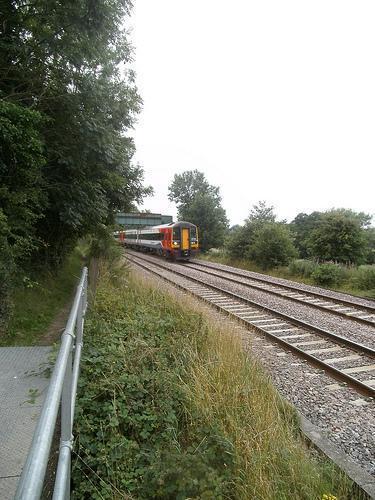How many train tracks are in the photo?
Give a very brief answer. 2. How many trains are in the photo?
Give a very brief answer. 1. 